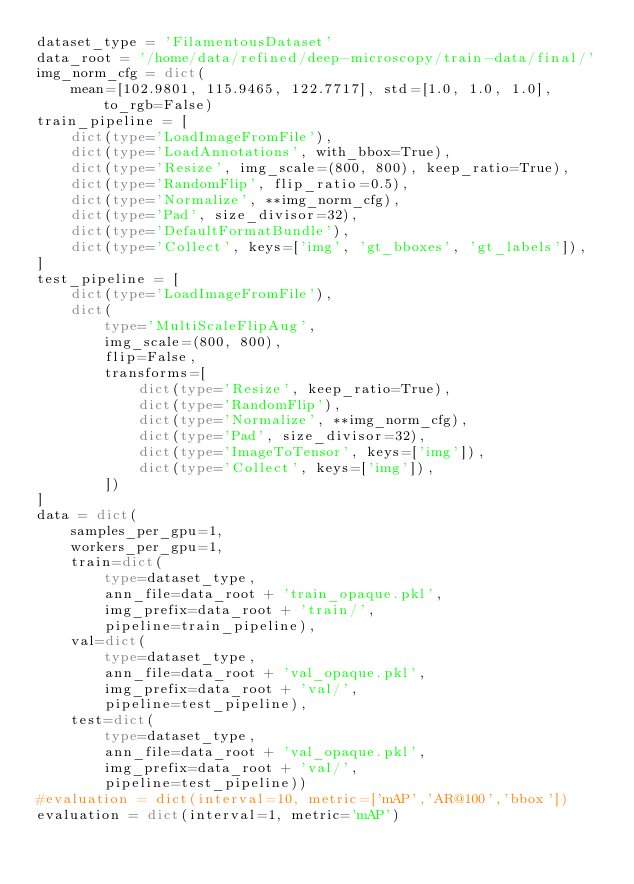<code> <loc_0><loc_0><loc_500><loc_500><_Python_>dataset_type = 'FilamentousDataset'
data_root = '/home/data/refined/deep-microscopy/train-data/final/'
img_norm_cfg = dict(
    mean=[102.9801, 115.9465, 122.7717], std=[1.0, 1.0, 1.0], to_rgb=False)
train_pipeline = [
    dict(type='LoadImageFromFile'),
    dict(type='LoadAnnotations', with_bbox=True),
    dict(type='Resize', img_scale=(800, 800), keep_ratio=True),
    dict(type='RandomFlip', flip_ratio=0.5),
    dict(type='Normalize', **img_norm_cfg),
    dict(type='Pad', size_divisor=32),
    dict(type='DefaultFormatBundle'),
    dict(type='Collect', keys=['img', 'gt_bboxes', 'gt_labels']),
]
test_pipeline = [
    dict(type='LoadImageFromFile'),
    dict(
        type='MultiScaleFlipAug',
        img_scale=(800, 800),
        flip=False,
        transforms=[
            dict(type='Resize', keep_ratio=True),
            dict(type='RandomFlip'),
            dict(type='Normalize', **img_norm_cfg),
            dict(type='Pad', size_divisor=32),
            dict(type='ImageToTensor', keys=['img']),
            dict(type='Collect', keys=['img']),
        ])
]
data = dict(
    samples_per_gpu=1,
    workers_per_gpu=1,
    train=dict(
        type=dataset_type,
        ann_file=data_root + 'train_opaque.pkl',
        img_prefix=data_root + 'train/',
        pipeline=train_pipeline),
    val=dict(
        type=dataset_type,
        ann_file=data_root + 'val_opaque.pkl',
        img_prefix=data_root + 'val/',
        pipeline=test_pipeline),
    test=dict(
        type=dataset_type,
        ann_file=data_root + 'val_opaque.pkl',
        img_prefix=data_root + 'val/',
        pipeline=test_pipeline))
#evaluation = dict(interval=10, metric=['mAP','AR@100','bbox'])
evaluation = dict(interval=1, metric='mAP')
</code> 